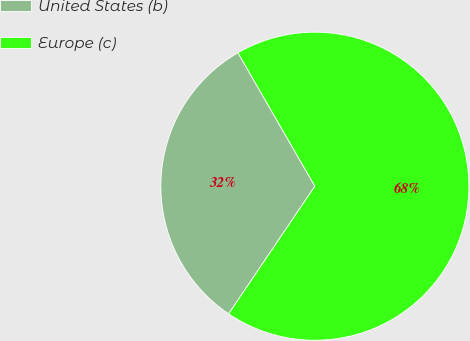<chart> <loc_0><loc_0><loc_500><loc_500><pie_chart><fcel>United States (b)<fcel>Europe (c)<nl><fcel>32.21%<fcel>67.79%<nl></chart> 